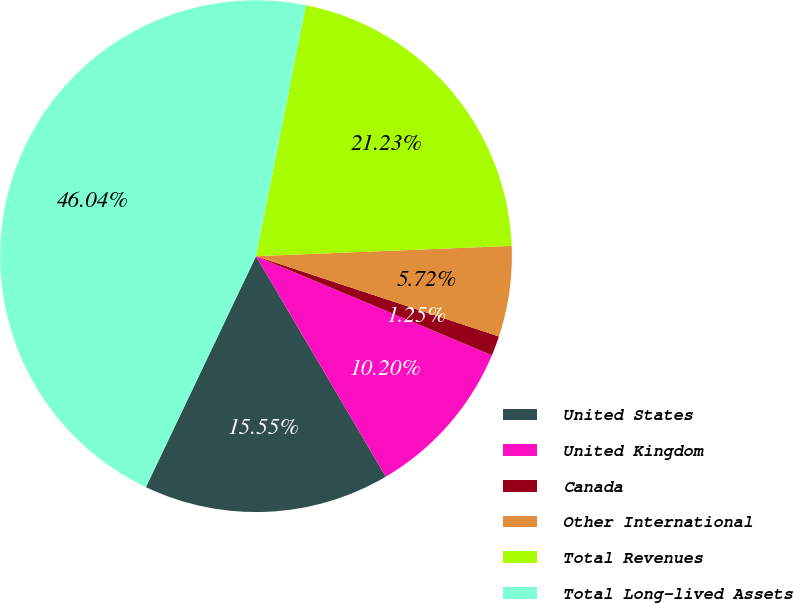Convert chart. <chart><loc_0><loc_0><loc_500><loc_500><pie_chart><fcel>United States<fcel>United Kingdom<fcel>Canada<fcel>Other International<fcel>Total Revenues<fcel>Total Long-lived Assets<nl><fcel>15.55%<fcel>10.2%<fcel>1.25%<fcel>5.72%<fcel>21.23%<fcel>46.04%<nl></chart> 